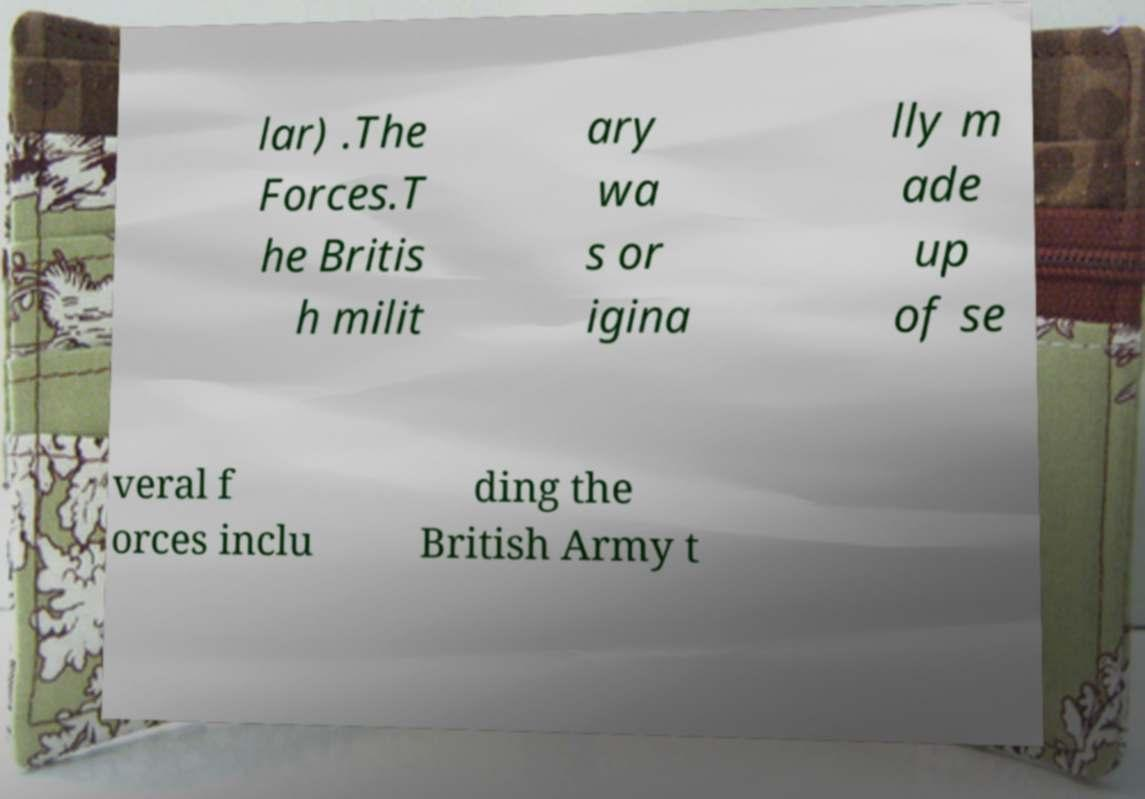Please read and relay the text visible in this image. What does it say? lar) .The Forces.T he Britis h milit ary wa s or igina lly m ade up of se veral f orces inclu ding the British Army t 